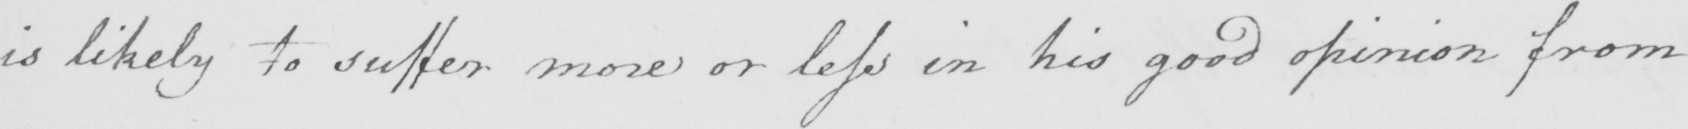Can you tell me what this handwritten text says? is likely to suffer more or less in his good opinion from 